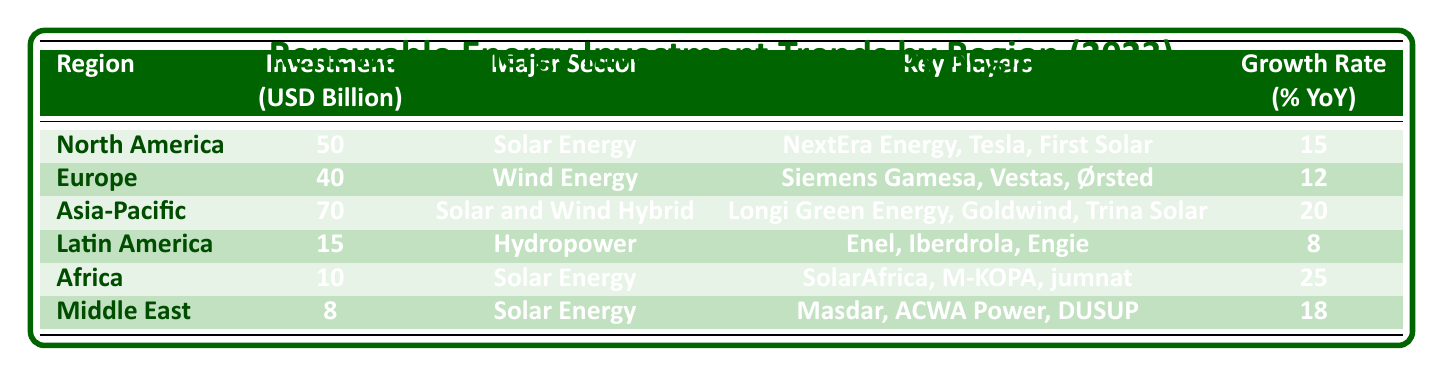What is the total investment for North America and Europe? The table shows that North America's investment is 50 billion and Europe's investment is 40 billion. Adding these two amounts gives 50 + 40 = 90 billion.
Answer: 90 billion Which region has the highest investment in renewable energy? From the table, Asia-Pacific has the highest investment at 70 billion.
Answer: Asia-Pacific Is the growth rate for Latin America higher than the growth rate for North America? The table indicates Latin America's growth rate is 8%, whereas North America's is 15%. Comparing these two values, 8% is not greater than 15%, hence the answer is no.
Answer: No What is the major sector for the region with the lowest investment? The region with the lowest investment is the Middle East with 8 billion. According to the table, its major sector is solar energy.
Answer: Solar Energy What is the average investment across all regions listed in the table? To find the average investment, sum the investments: 50 + 40 + 70 + 15 + 10 + 8 = 193 billion. There are 6 regions so, 193/6 = 32.17 billion.
Answer: 32.17 billion Is there any region that has a higher investment in solar energy than Africa? The investment in solar energy for Africa is 10 billion. North America has an investment of 50 billion in solar energy, making it greater than Africa's. Thus, the answer is yes.
Answer: Yes Which region is invested primarily in hydropower and what is its investment amount? The only region focusing on hydropower is Latin America, which has an investment amount of 15 billion.
Answer: 15 billion 